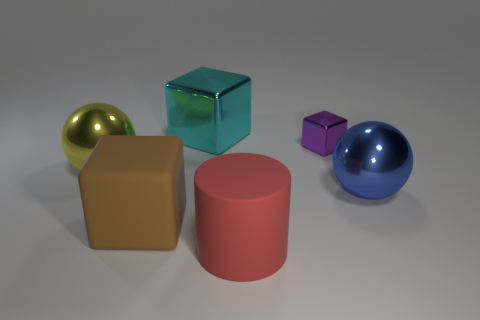What is the material of the sphere that is right of the cube that is in front of the big sphere on the left side of the rubber block? The sphere to the right of the cube, which is in front of the larger sphere on the left side of the rubber block, appears to have a smooth and reflective surface, which suggests that it could be made of a polished metal. 